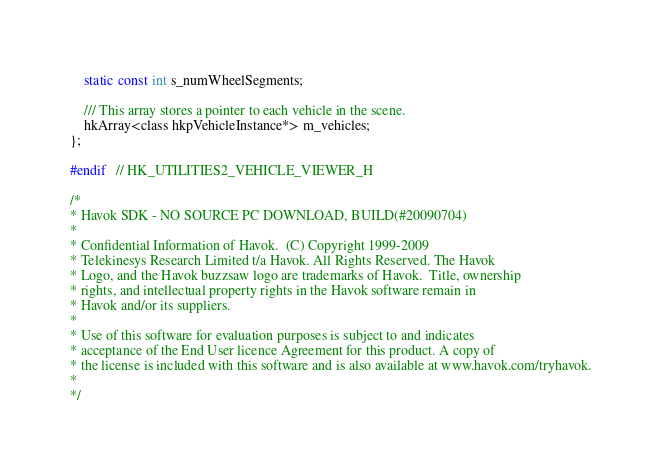<code> <loc_0><loc_0><loc_500><loc_500><_C_>	static const int s_numWheelSegments;

	/// This array stores a pointer to each vehicle in the scene.
	hkArray<class hkpVehicleInstance*> m_vehicles;
};

#endif	// HK_UTILITIES2_VEHICLE_VIEWER_H

/*
* Havok SDK - NO SOURCE PC DOWNLOAD, BUILD(#20090704)
* 
* Confidential Information of Havok.  (C) Copyright 1999-2009
* Telekinesys Research Limited t/a Havok. All Rights Reserved. The Havok
* Logo, and the Havok buzzsaw logo are trademarks of Havok.  Title, ownership
* rights, and intellectual property rights in the Havok software remain in
* Havok and/or its suppliers.
* 
* Use of this software for evaluation purposes is subject to and indicates
* acceptance of the End User licence Agreement for this product. A copy of
* the license is included with this software and is also available at www.havok.com/tryhavok.
* 
*/
</code> 